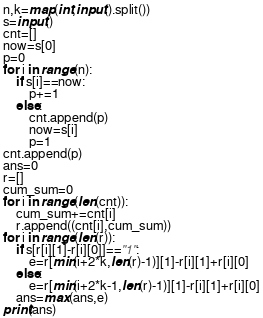<code> <loc_0><loc_0><loc_500><loc_500><_Python_>n,k=map(int,input().split())
s=input()
cnt=[]
now=s[0]
p=0
for i in range(n):
	if s[i]==now:
		p+=1
	else:
		cnt.append(p)
		now=s[i]
		p=1
cnt.append(p)
ans=0
r=[]
cum_sum=0
for i in range(len(cnt)):
	cum_sum+=cnt[i]
	r.append((cnt[i],cum_sum))
for i in range(len(r)):
	if s[r[i][1]-r[i][0]]=="1":
		e=r[min(i+2*k,len(r)-1)][1]-r[i][1]+r[i][0]
	else:
		e=r[min(i+2*k-1,len(r)-1)][1]-r[i][1]+r[i][0]
	ans=max(ans,e)
print(ans)</code> 